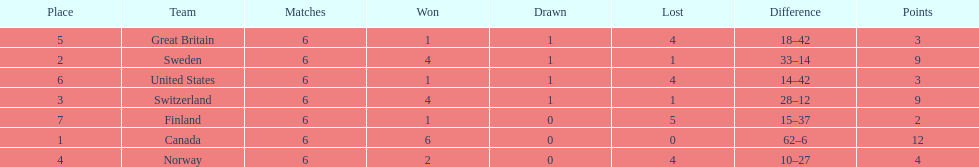How many teams won 6 matches? 1. 